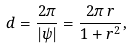<formula> <loc_0><loc_0><loc_500><loc_500>d = \frac { 2 \pi } { | \psi | } = \frac { 2 \pi \, r } { 1 + r ^ { 2 } } ,</formula> 